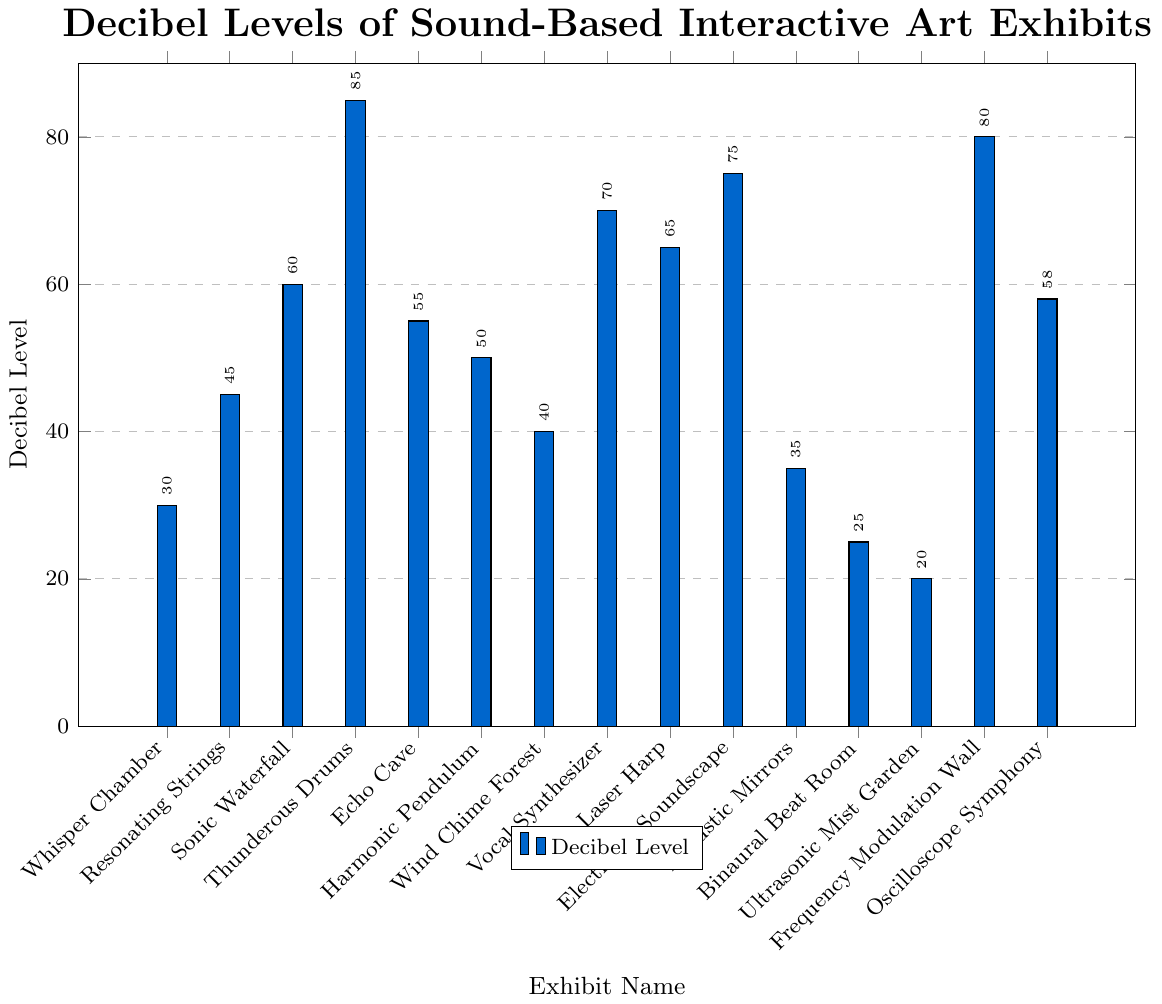Which exhibit has the highest decibel level? From the bar chart, we observe that the highest bar represents Thunderous Drums at 85 decibels.
Answer: Thunderous Drums What is the difference in decibel levels between Sonic Waterfall and Echo Cave? The decibel level for Sonic Waterfall is 60, and for Echo Cave, it is 55. The difference is 60 - 55.
Answer: 5 Which exhibits have a decibel level greater than 70? The exhibits with bars extending beyond the 70-decibel mark are Thunderous Drums (85), Frequency Modulation Wall (80), and Electronic Soundscape (75).
Answer: Thunderous Drums, Frequency Modulation Wall, and Electronic Soundscape What is the median decibel level of all exhibits? To find the median, we first list all decibel levels in ascending order: 20, 25, 30, 35, 40, 45, 50, 55, 58, 60, 65, 70, 75, 80, 85. The median is the middle value in this ordered list, which is the 8th value.
Answer: 55 How many exhibits have a decibel level less than 40? The exhibits with decibel levels less than 40 are Ultrasonic Mist Garden (20), Binaural Beat Room (25), Whisper Chamber (30), and Acoustic Mirrors (35). Counting them, we have 4 exhibits.
Answer: 4 What is the average decibel level of all exhibits? Summing all decibel levels: 30 + 45 + 60 + 85 + 55 + 50 + 40 + 70 + 65 + 75 + 35 + 25 + 20 + 80 + 58 = 793. There are 15 exhibits, so we divide the sum by 15: 793 / 15 ≈ 52.87.
Answer: 52.87 Which exhibit has the lowest decibel level? Looking at the bar chart, the shortest bar represents Ultrasonic Mist Garden at 20 decibels.
Answer: Ultrasonic Mist Garden How much higher is the decibel level of Electronic Soundscape compared to Harmonic Pendulum? The decibel level of Electronic Soundscape is 75, and for Harmonic Pendulum, it is 50. The difference is 75 - 50.
Answer: 25 Which exhibit has a color distinctively different from the others in the bar chart? All bars in the chart are filled with a consistent color (custom blue). Thus, there isn't an exhibit with a distinctively different color.
Answer: None What is the total decibel level of Whisper Chamber, Resonating Strings, and Sonic Waterfall combined? Summing the decibel levels of Whisper Chamber (30), Resonating Strings (45), and Sonic Waterfall (60): 30 + 45 + 60 = 135.
Answer: 135 